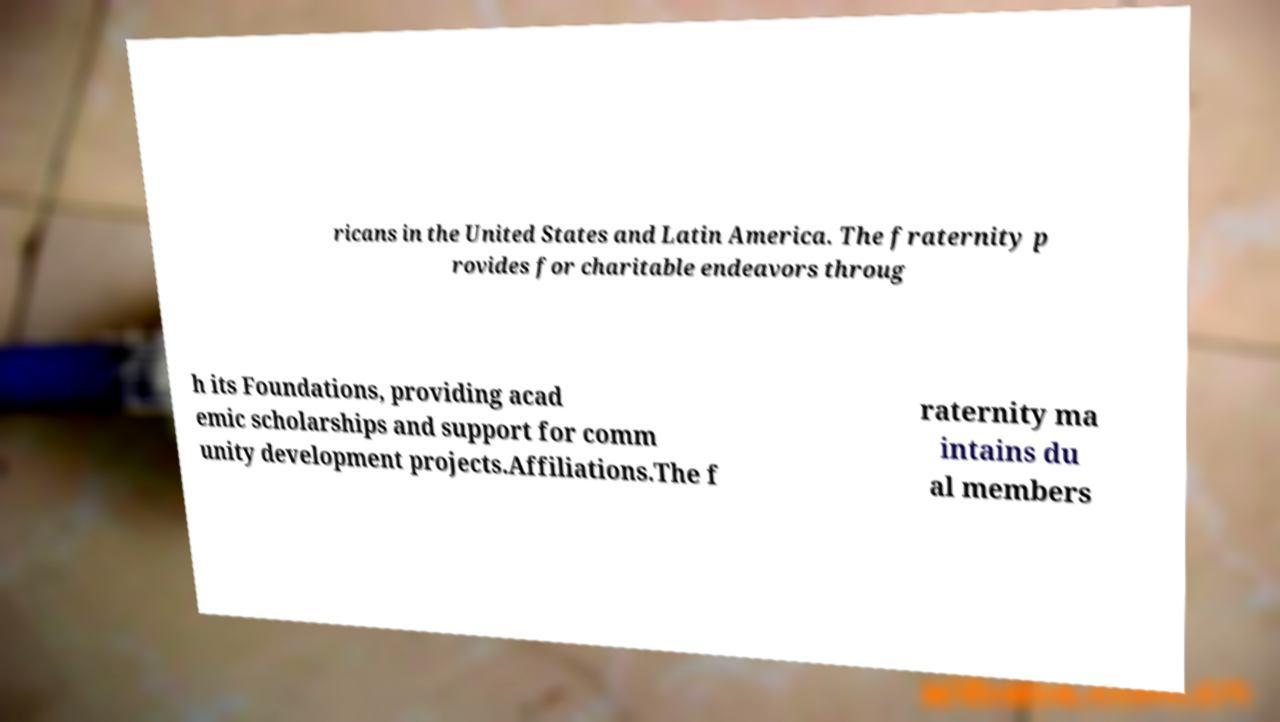For documentation purposes, I need the text within this image transcribed. Could you provide that? ricans in the United States and Latin America. The fraternity p rovides for charitable endeavors throug h its Foundations, providing acad emic scholarships and support for comm unity development projects.Affiliations.The f raternity ma intains du al members 